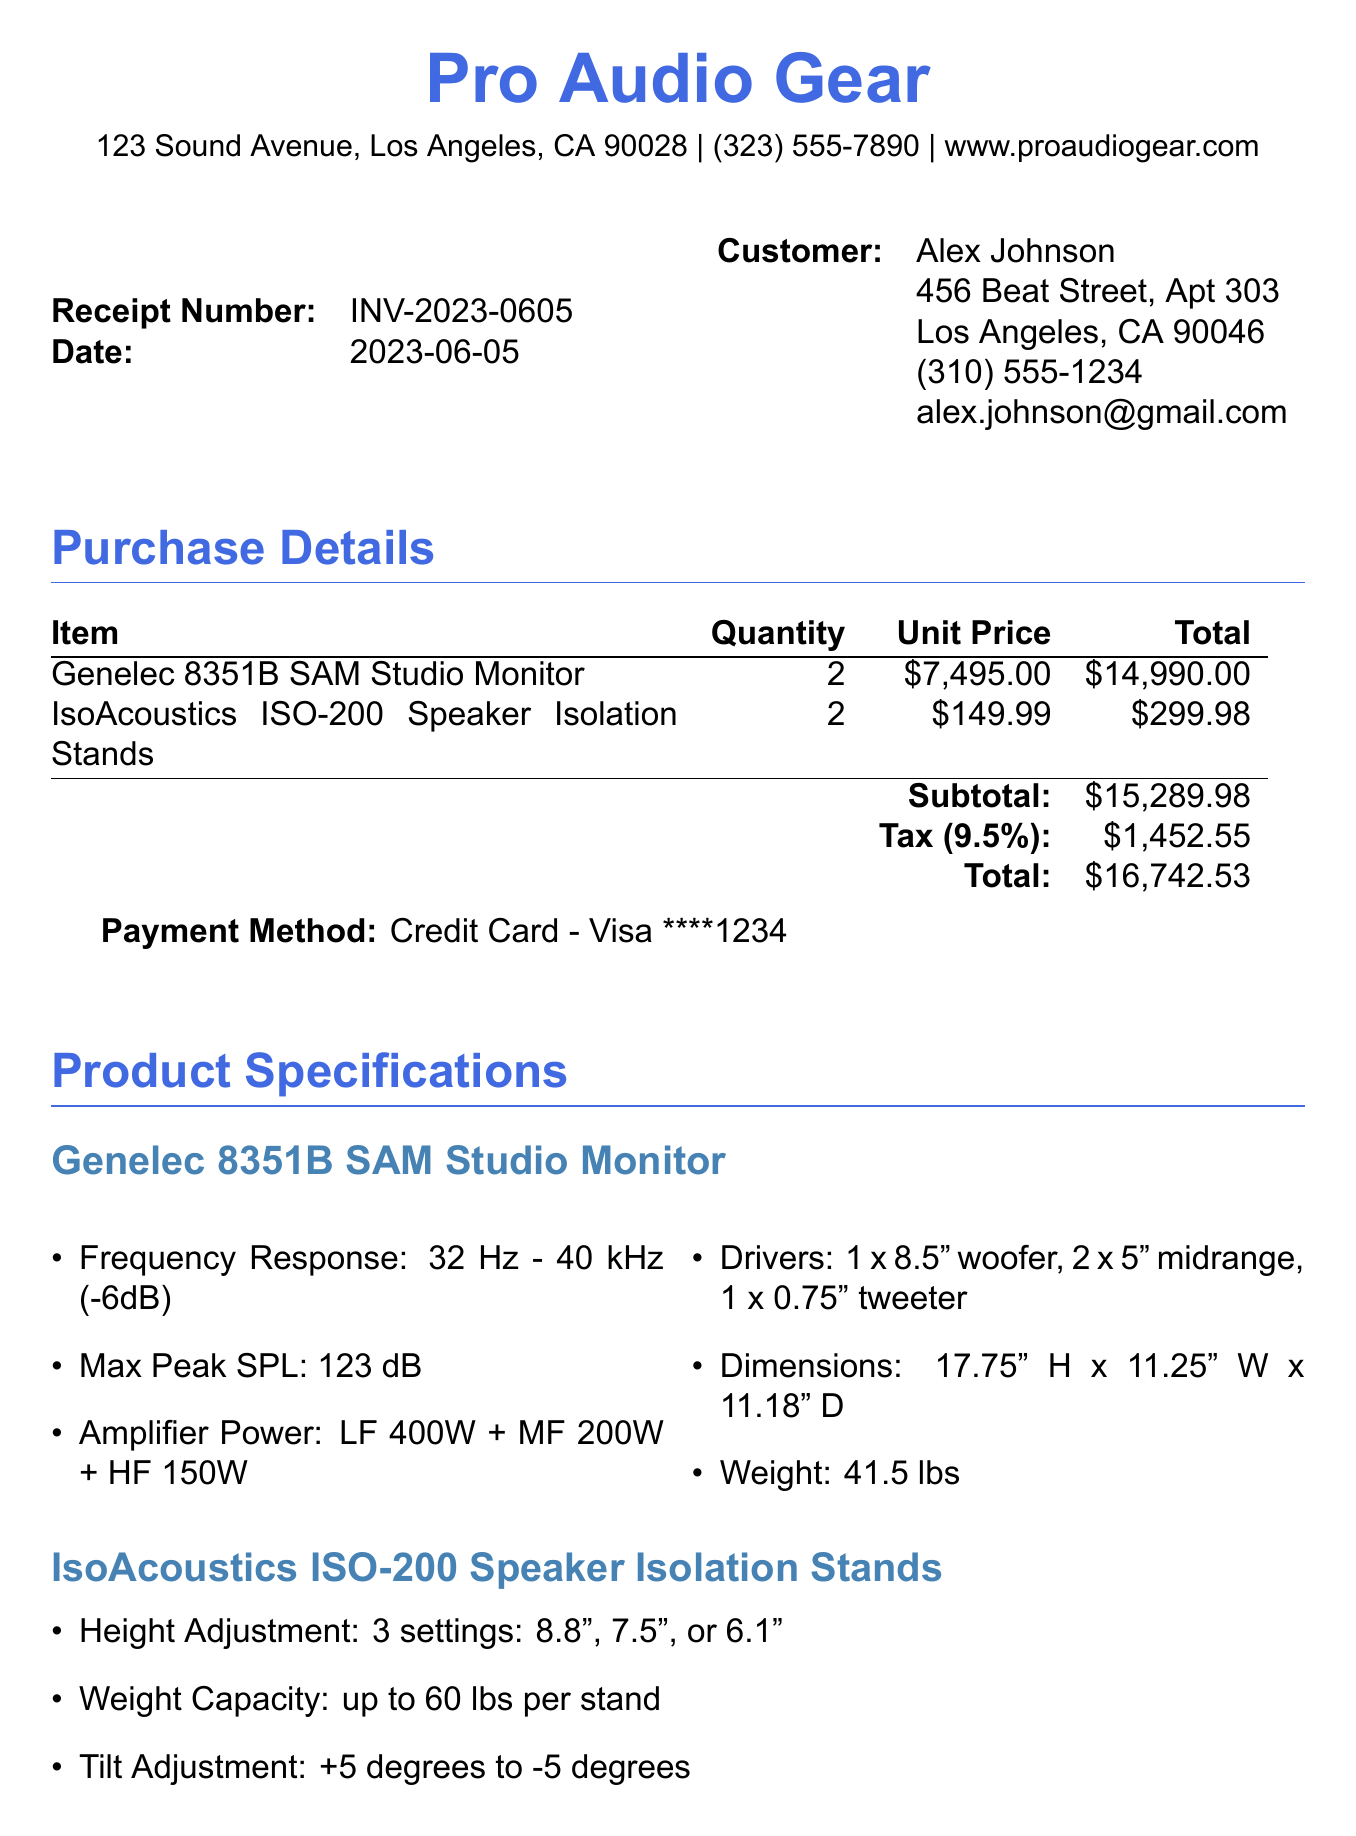What is the receipt number? The receipt number is stated at the top of the document.
Answer: INV-2023-0605 What is the date of purchase? The date of purchase is included in the header section of the document.
Answer: 2023-06-05 How many Genelec 8351B monitors were purchased? The quantity of Genelec 8351B monitors is listed next to the product name.
Answer: 2 What is the total amount of tax charged? The tax amount is calculated and shown in the purchase details table.
Answer: 1452.55 What is the warranty duration for the IsoAcoustics ISO-200? The warranty information specifies the duration for each product.
Answer: 2 years What is the maximum peak SPL for the Genelec 8351B? The specifications section provides detailed technical information about the product.
Answer: 123 dB What is the payment method used for this transaction? The payment method is clearly stated in the payment section of the document.
Answer: Credit Card - Visa ****1234 What are the additional notes about the product recommendations? The additional notes section contains guidance and insights for the customer about the purchase.
Answer: As a rising music producer and DJ, these Genelec 8351B monitors will significantly enhance your studio setup What is the address of the vendor? The vendor's address is provided in the header information.
Answer: 123 Sound Avenue, Los Angeles, CA 90028 